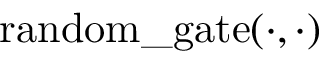Convert formula to latex. <formula><loc_0><loc_0><loc_500><loc_500>r a n d o m \_ g a t e ( \cdot , \cdot )</formula> 